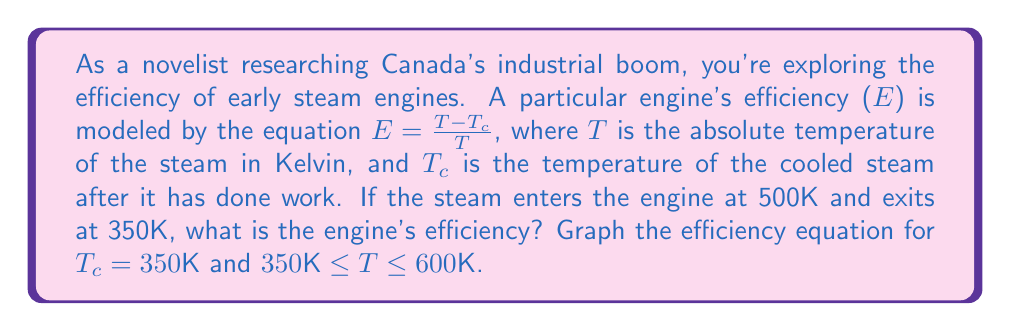Can you solve this math problem? 1) We are given the efficiency equation:
   $E = \frac{T - T_c}{T}$

2) We know:
   $T = 500K$ (steam entry temperature)
   $T_c = 350K$ (steam exit temperature)

3) Let's substitute these values into the equation:
   $E = \frac{500K - 350K}{500K}$

4) Simplify:
   $E = \frac{150K}{500K} = 0.3$

5) To express as a percentage, multiply by 100:
   $E = 0.3 \times 100\% = 30\%$

6) For the graph, we'll use the equation $E = \frac{T - 350}{T}$ for $350K \leq T \leq 600K$

7) Here's the Asymptote code to generate the graph:

[asy]
import graph;
size(200,200);

real f(real x) {return (x-350)/x;}

draw(graph(f,350,600));

xaxis("T (K)",0,600,Arrow);
yaxis("Efficiency",0,1,Arrow);

label("E = (T-350)/T",point(SW),S);
[/asy]

The graph shows the efficiency increasing as the temperature increases, but with diminishing returns at higher temperatures.
Answer: 30% 